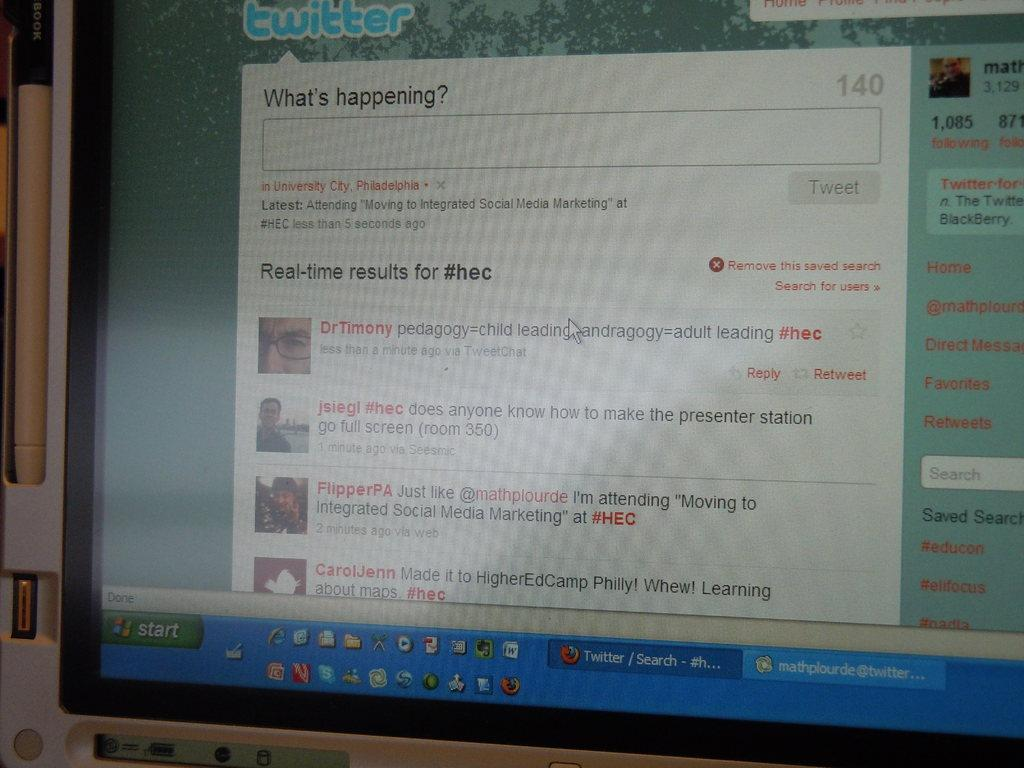<image>
Render a clear and concise summary of the photo. A display is opened to the twitter website. 